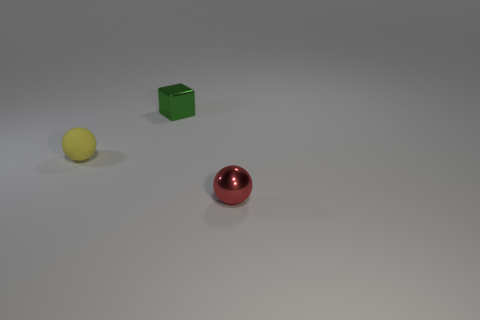There is a metallic object to the right of the metallic thing behind the small yellow rubber object; what is its shape?
Provide a short and direct response. Sphere. Are there any yellow shiny things that have the same size as the rubber ball?
Your answer should be compact. No. Is the number of red matte cylinders greater than the number of small yellow rubber objects?
Your response must be concise. No. Is the size of the ball on the left side of the small red metallic ball the same as the thing behind the yellow matte object?
Ensure brevity in your answer.  Yes. What number of tiny objects are in front of the green thing and on the left side of the red sphere?
Ensure brevity in your answer.  1. There is a metallic thing that is the same shape as the tiny rubber object; what color is it?
Ensure brevity in your answer.  Red. Are there fewer large purple rubber blocks than yellow things?
Give a very brief answer. Yes. There is a yellow matte object; does it have the same size as the thing right of the green object?
Provide a succinct answer. Yes. What is the color of the sphere on the right side of the shiny object that is on the left side of the red sphere?
Your answer should be compact. Red. How many objects are either metal things behind the small metallic ball or tiny objects that are behind the tiny red metallic sphere?
Give a very brief answer. 2. 